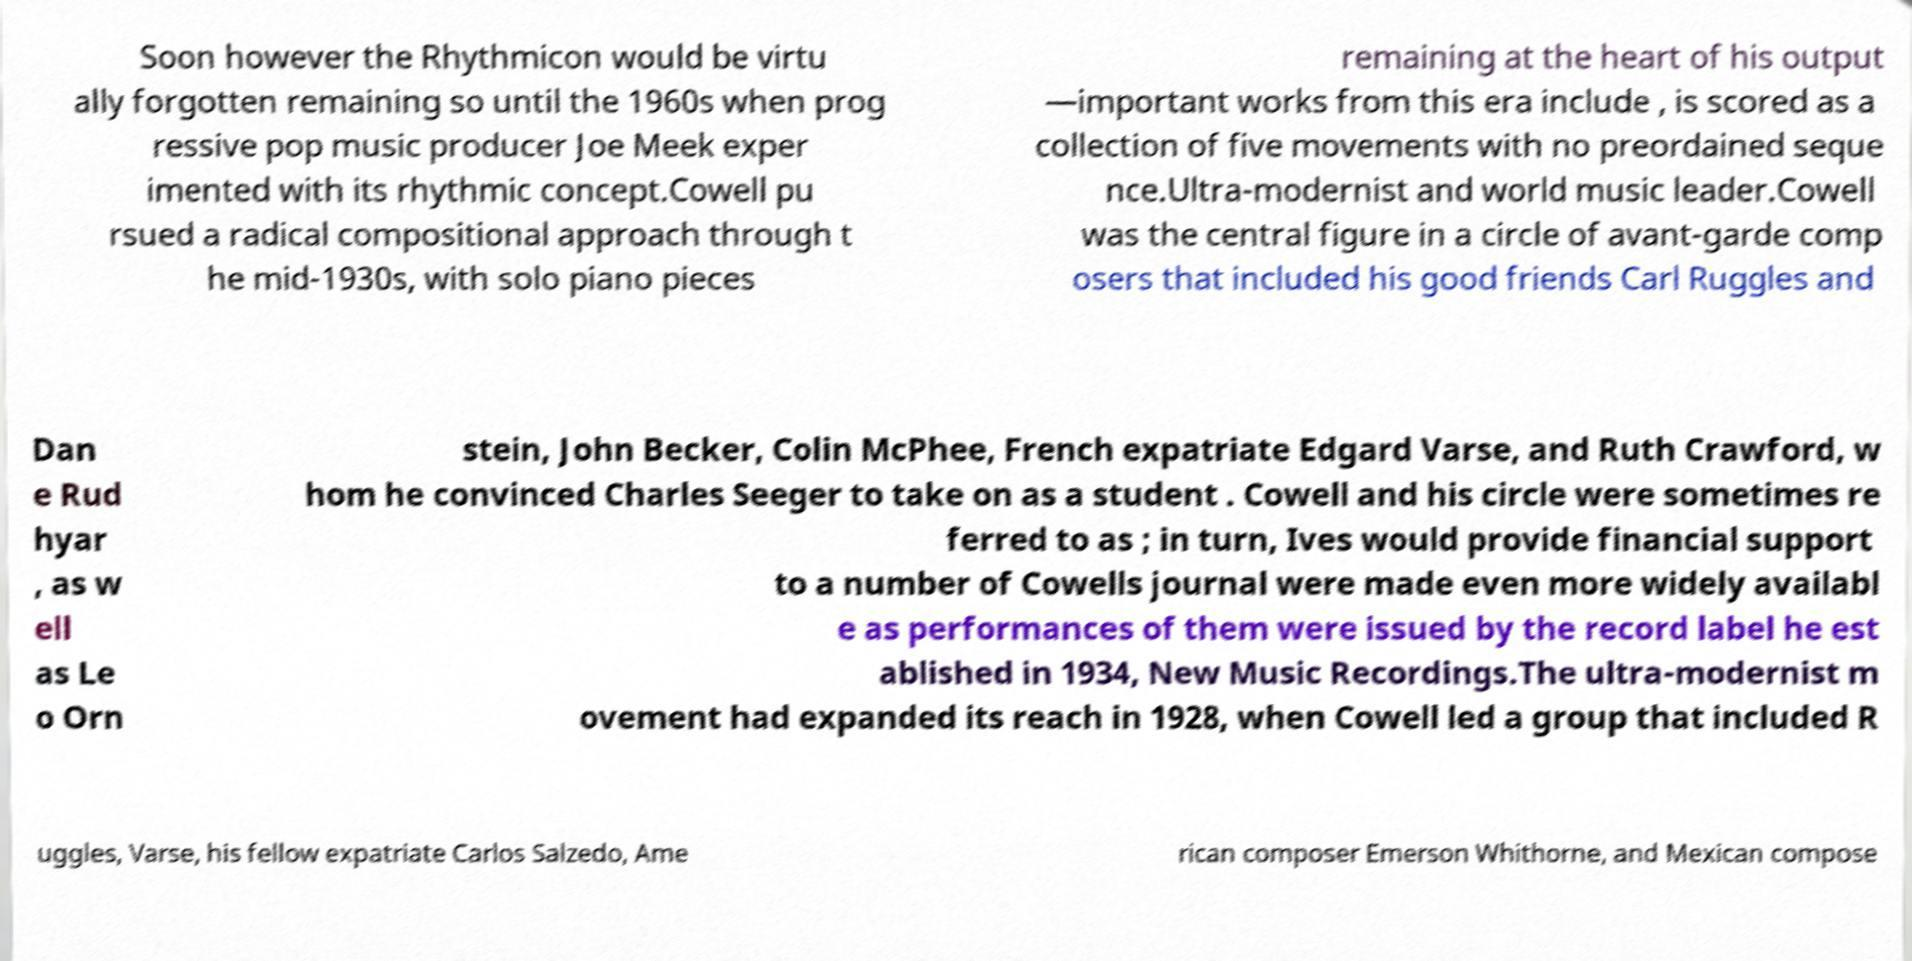Could you assist in decoding the text presented in this image and type it out clearly? Soon however the Rhythmicon would be virtu ally forgotten remaining so until the 1960s when prog ressive pop music producer Joe Meek exper imented with its rhythmic concept.Cowell pu rsued a radical compositional approach through t he mid-1930s, with solo piano pieces remaining at the heart of his output —important works from this era include , is scored as a collection of five movements with no preordained seque nce.Ultra-modernist and world music leader.Cowell was the central figure in a circle of avant-garde comp osers that included his good friends Carl Ruggles and Dan e Rud hyar , as w ell as Le o Orn stein, John Becker, Colin McPhee, French expatriate Edgard Varse, and Ruth Crawford, w hom he convinced Charles Seeger to take on as a student . Cowell and his circle were sometimes re ferred to as ; in turn, Ives would provide financial support to a number of Cowells journal were made even more widely availabl e as performances of them were issued by the record label he est ablished in 1934, New Music Recordings.The ultra-modernist m ovement had expanded its reach in 1928, when Cowell led a group that included R uggles, Varse, his fellow expatriate Carlos Salzedo, Ame rican composer Emerson Whithorne, and Mexican compose 